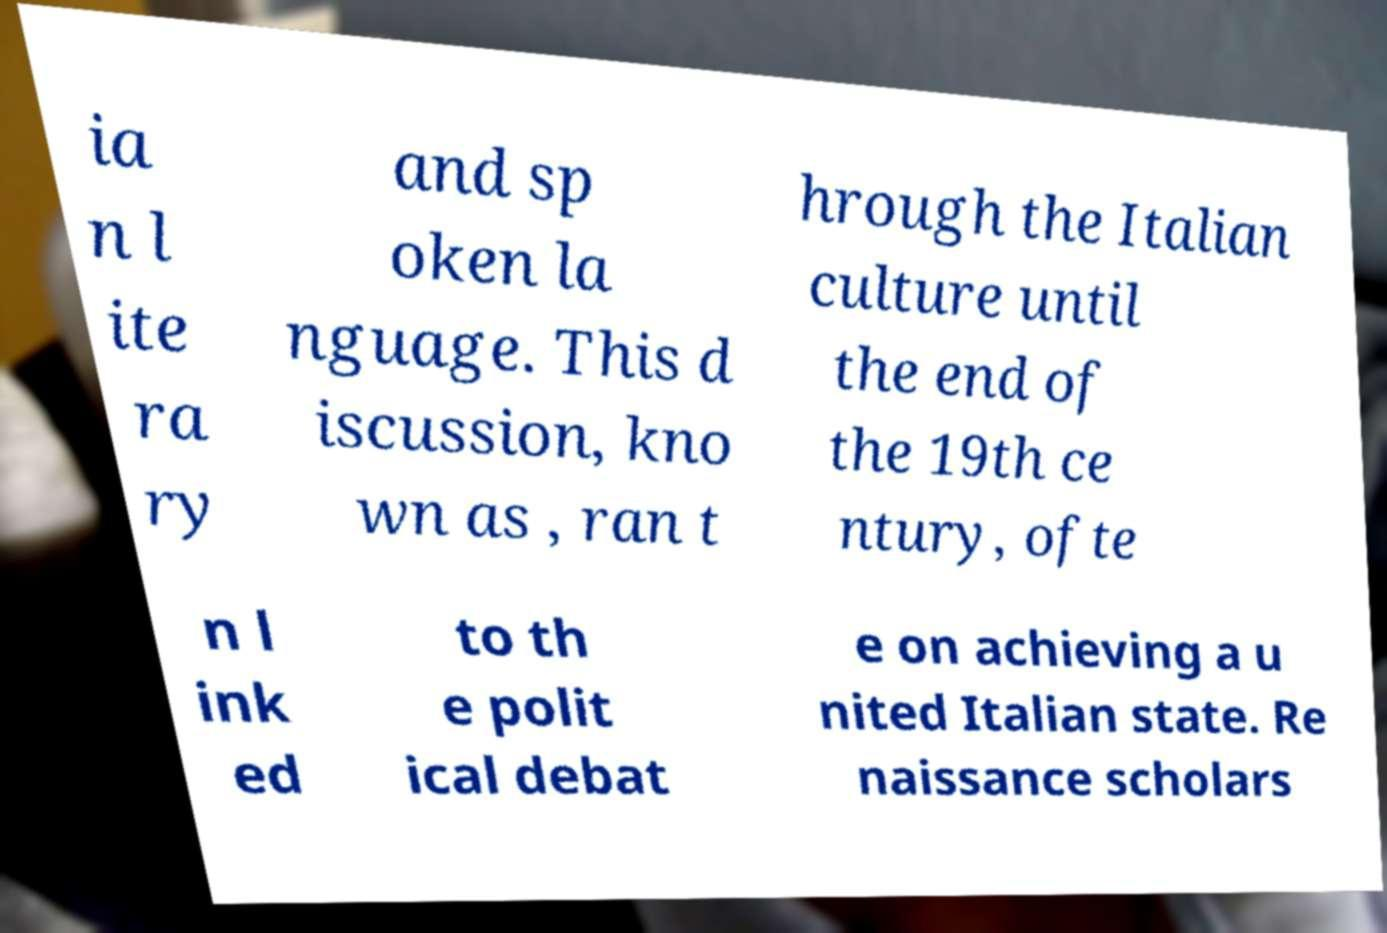What messages or text are displayed in this image? I need them in a readable, typed format. ia n l ite ra ry and sp oken la nguage. This d iscussion, kno wn as , ran t hrough the Italian culture until the end of the 19th ce ntury, ofte n l ink ed to th e polit ical debat e on achieving a u nited Italian state. Re naissance scholars 